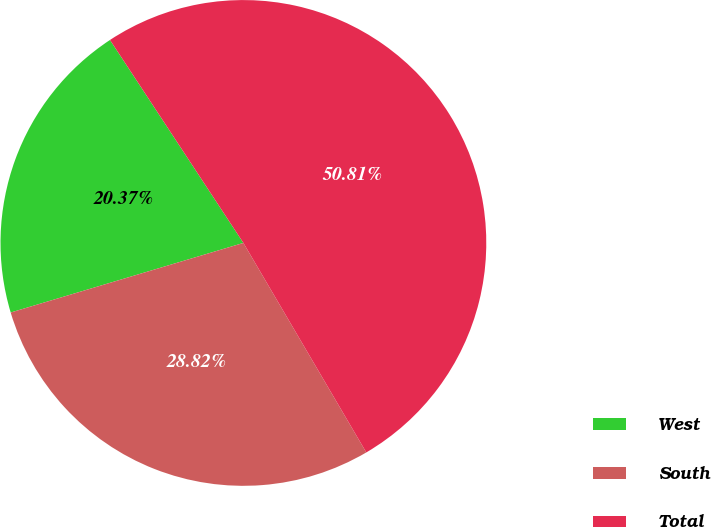<chart> <loc_0><loc_0><loc_500><loc_500><pie_chart><fcel>West<fcel>South<fcel>Total<nl><fcel>20.37%<fcel>28.82%<fcel>50.81%<nl></chart> 